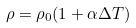Convert formula to latex. <formula><loc_0><loc_0><loc_500><loc_500>\rho = \rho _ { 0 } ( 1 + \alpha \Delta T )</formula> 